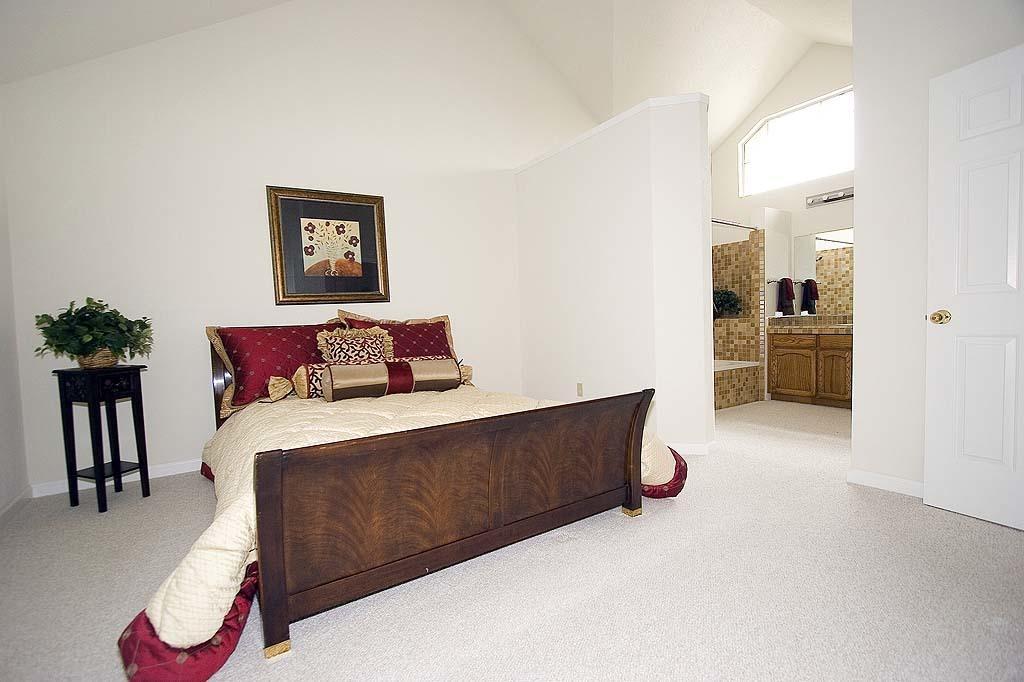Can you describe this image briefly? This picture is taken in a room, In the middle there is a brown color bed on that bed there is a white color blanket, In the left side there is a black color table on that table there is a green color flower box, There is a white color wall and there is a black color picture. 